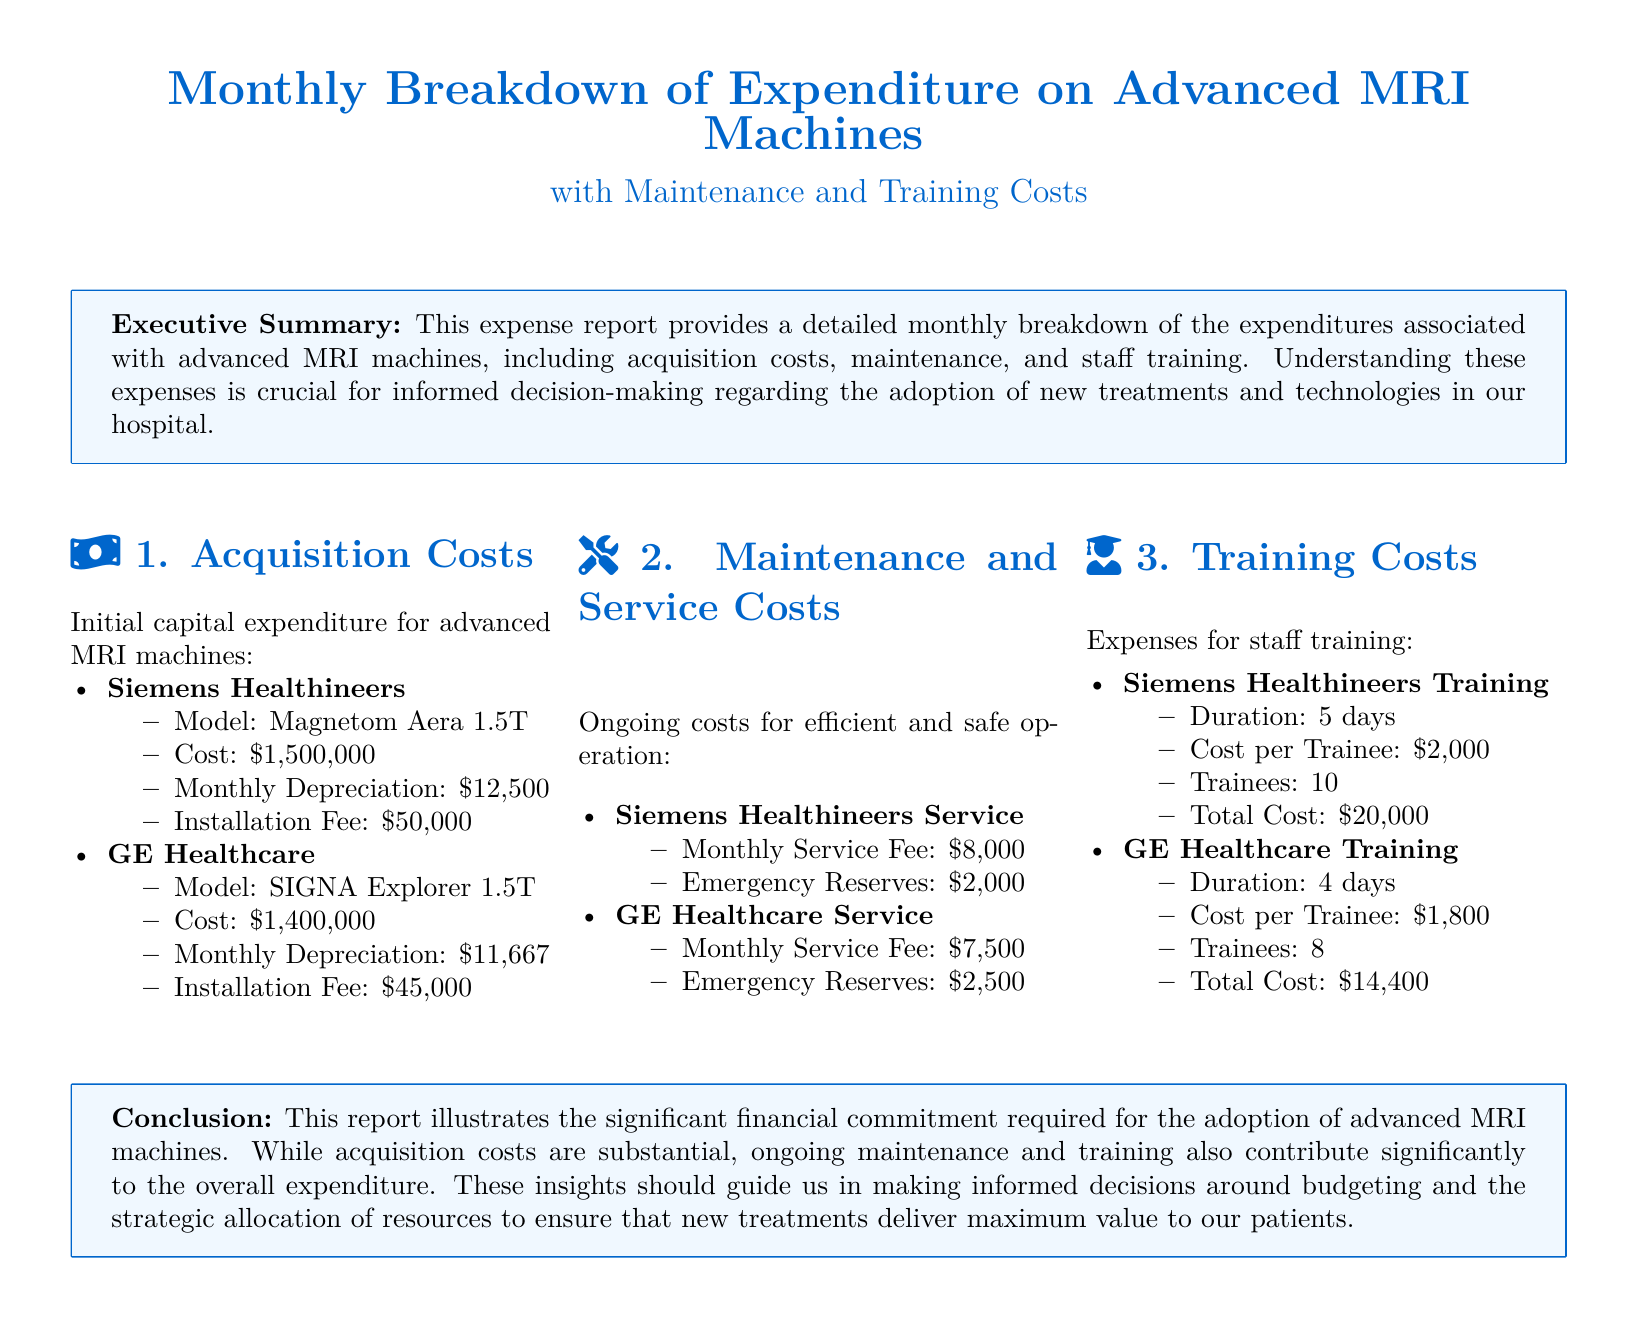what is the cost of the Siemens Healthineers MRI machine? The cost of the Siemens Healthineers MRI machine, Magnetom Aera 1.5T, is mentioned in the document.
Answer: $1,500,000 what is the monthly maintenance fee for GE Healthcare service? The document lists the monthly service fee for GE Healthcare service under maintenance costs.
Answer: $7,500 how many trainees were involved in Siemens Healthineers training? The document specifies the number of trainees for Siemens Healthineers training under training costs.
Answer: 10 what is the total training cost for GE Healthcare? The total cost for GE Healthcare training can be derived from the information provided about cost per trainee and the number of trainees.
Answer: $14,400 what is the total monthly depreciation for both MRI machines? The total monthly depreciation combines the amounts for both Siemens Healthineers and GE Healthcare machines.
Answer: $24,167 